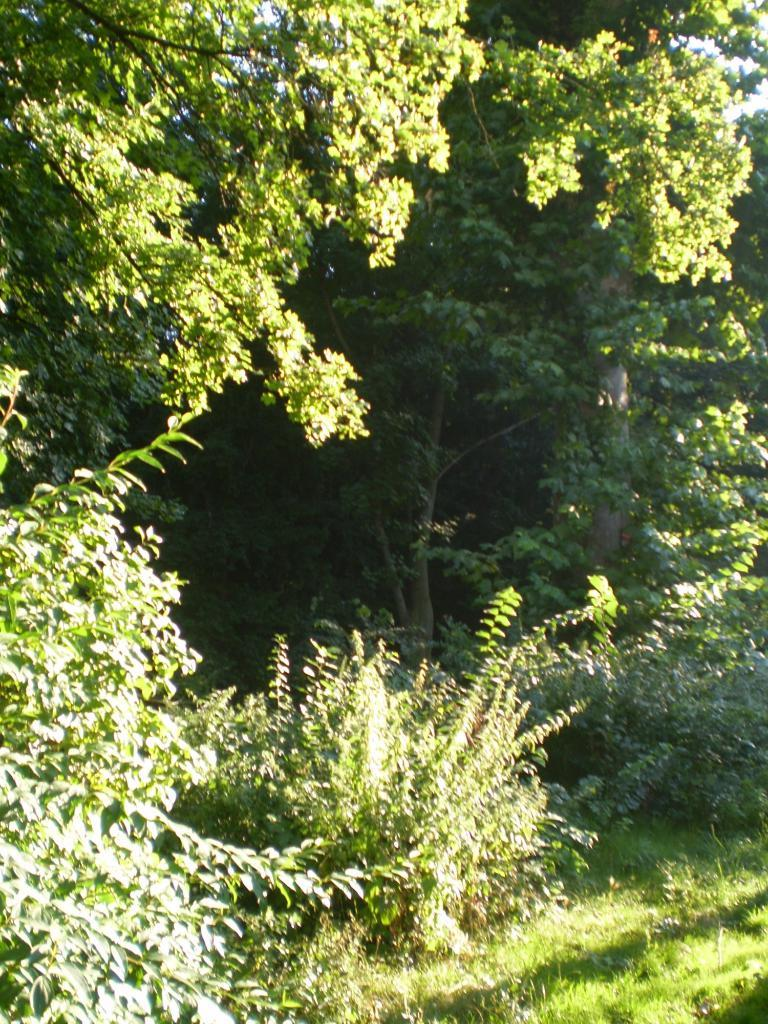What type of vegetation can be seen in the image? There are trees in the image. What color are the trees? The trees are green in color. What is on the ground in the image? There is grass on the ground in the image. What can be seen in the background of the image? The sky is visible in the background of the image. What type of bone can be seen in the image? There is no bone present in the image; it features trees, grass, and the sky. What is the reason for the protest in the image? There is no protest depicted in the image; it only shows trees, grass, and the sky. 